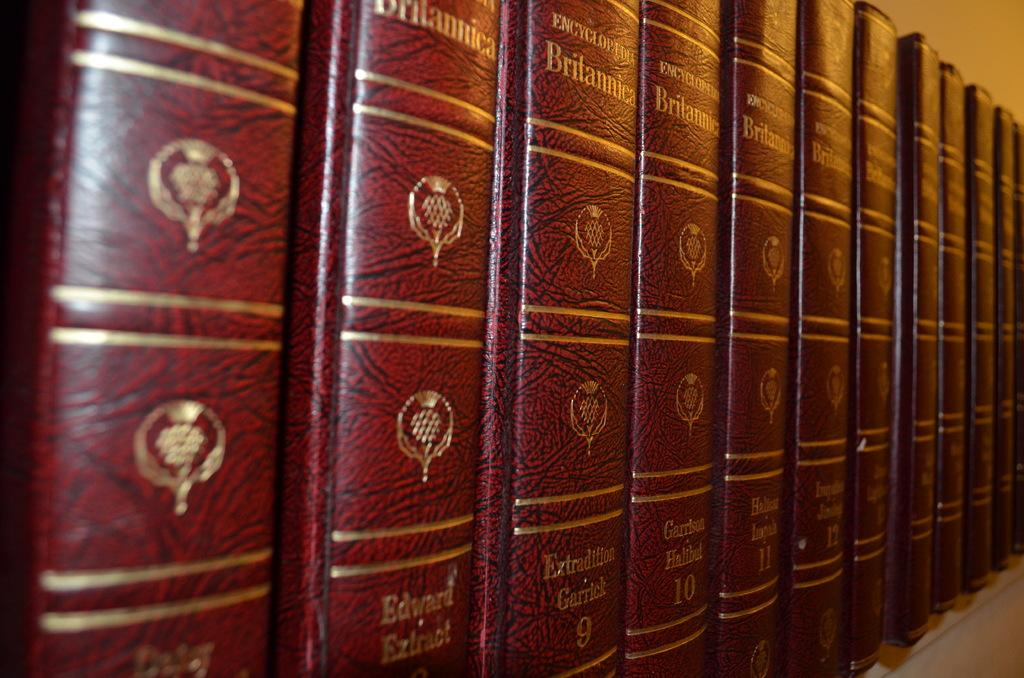<image>
Create a compact narrative representing the image presented. A row of red Encyclopedia Britannica books with gold lettering. 